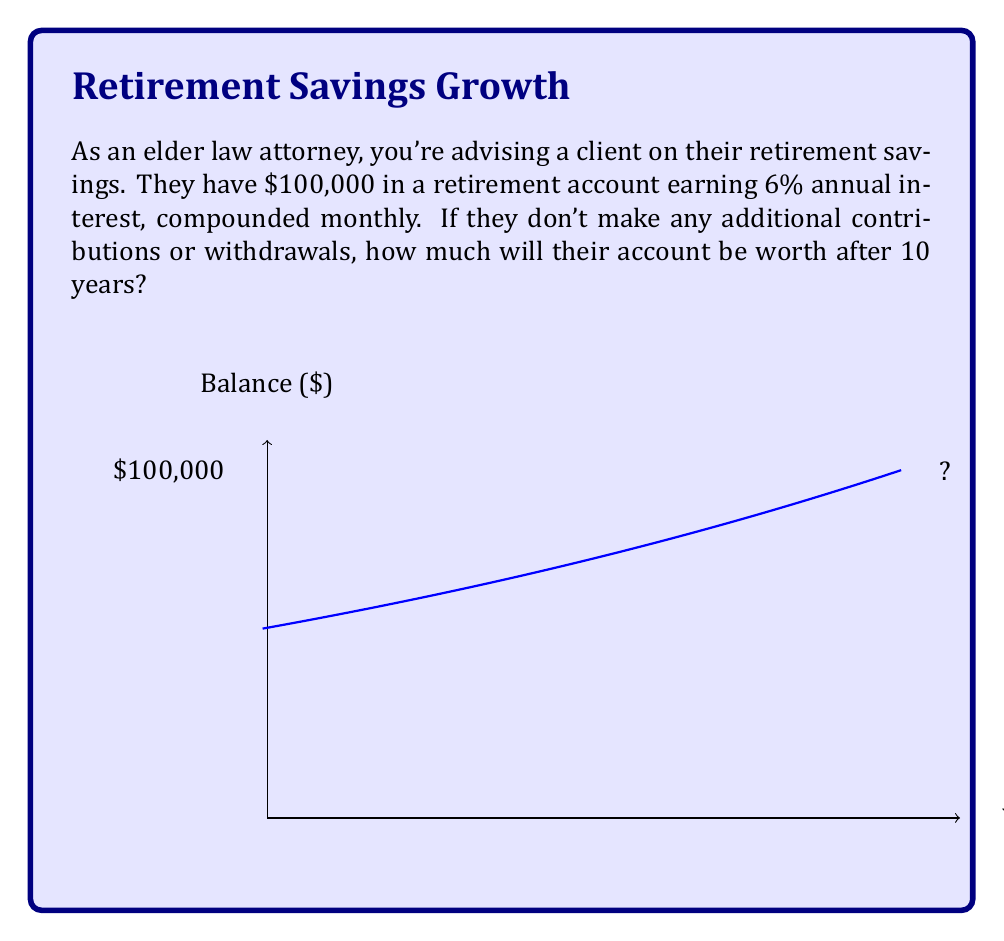Teach me how to tackle this problem. To solve this problem, we'll use the compound interest formula:

$$A = P(1 + \frac{r}{n})^{nt}$$

Where:
$A$ = final amount
$P$ = principal balance (initial investment)
$r$ = annual interest rate (as a decimal)
$n$ = number of times interest is compounded per year
$t$ = number of years

Given:
$P = $100,000
$r = 6\% = 0.06
$n = 12$ (compounded monthly)
$t = 10$ years

Let's substitute these values into the formula:

$$A = 100000(1 + \frac{0.06}{12})^{12 \cdot 10}$$

$$A = 100000(1 + 0.005)^{120}$$

$$A = 100000(1.005)^{120}$$

Using a calculator or computer:

$$A = 100000 \cdot 1.8194097$$

$$A = 181940.97$$

Therefore, after 10 years, the account will be worth $181,940.97.
Answer: $181,940.97 